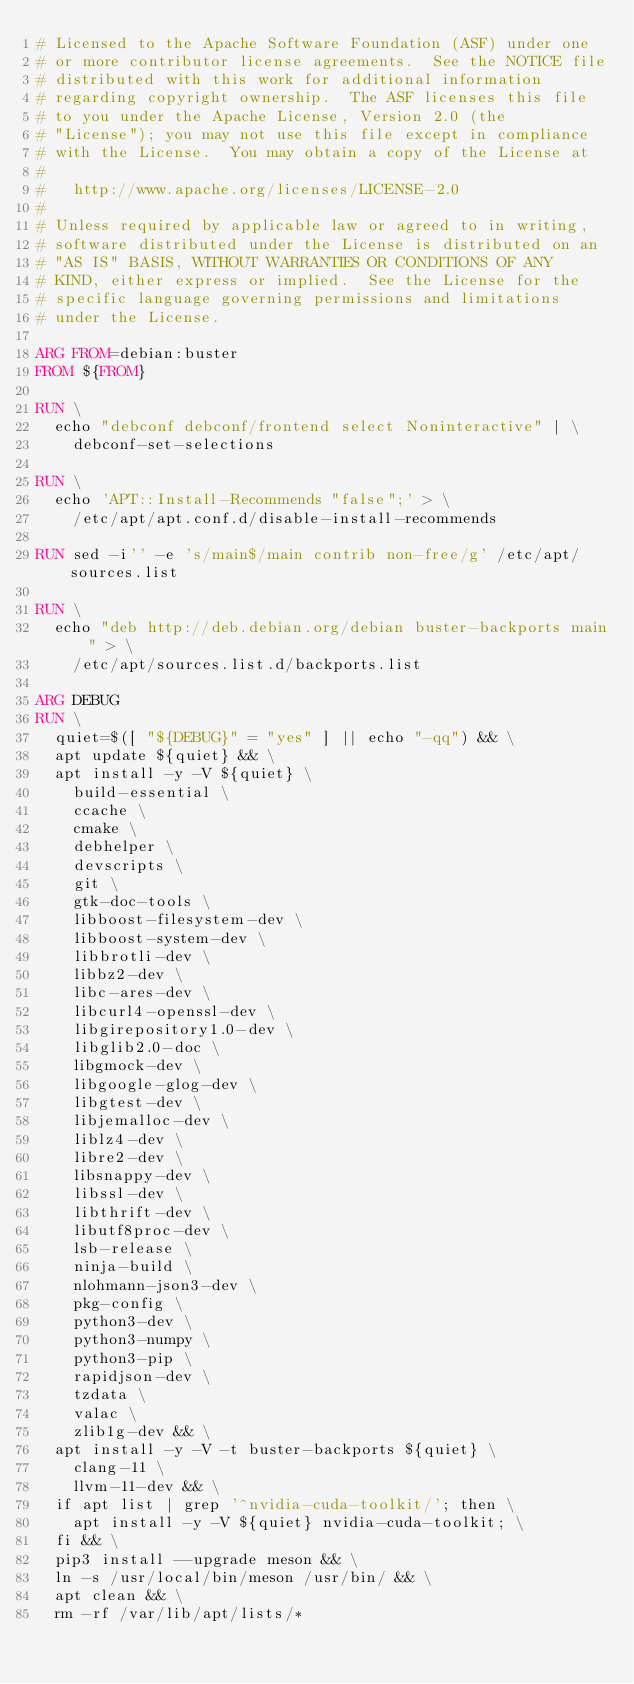Convert code to text. <code><loc_0><loc_0><loc_500><loc_500><_Dockerfile_># Licensed to the Apache Software Foundation (ASF) under one
# or more contributor license agreements.  See the NOTICE file
# distributed with this work for additional information
# regarding copyright ownership.  The ASF licenses this file
# to you under the Apache License, Version 2.0 (the
# "License"); you may not use this file except in compliance
# with the License.  You may obtain a copy of the License at
#
#   http://www.apache.org/licenses/LICENSE-2.0
#
# Unless required by applicable law or agreed to in writing,
# software distributed under the License is distributed on an
# "AS IS" BASIS, WITHOUT WARRANTIES OR CONDITIONS OF ANY
# KIND, either express or implied.  See the License for the
# specific language governing permissions and limitations
# under the License.

ARG FROM=debian:buster
FROM ${FROM}

RUN \
  echo "debconf debconf/frontend select Noninteractive" | \
    debconf-set-selections

RUN \
  echo 'APT::Install-Recommends "false";' > \
    /etc/apt/apt.conf.d/disable-install-recommends

RUN sed -i'' -e 's/main$/main contrib non-free/g' /etc/apt/sources.list

RUN \
  echo "deb http://deb.debian.org/debian buster-backports main" > \
    /etc/apt/sources.list.d/backports.list

ARG DEBUG
RUN \
  quiet=$([ "${DEBUG}" = "yes" ] || echo "-qq") && \
  apt update ${quiet} && \
  apt install -y -V ${quiet} \
    build-essential \
    ccache \
    cmake \
    debhelper \
    devscripts \
    git \
    gtk-doc-tools \
    libboost-filesystem-dev \
    libboost-system-dev \
    libbrotli-dev \
    libbz2-dev \
    libc-ares-dev \
    libcurl4-openssl-dev \
    libgirepository1.0-dev \
    libglib2.0-doc \
    libgmock-dev \
    libgoogle-glog-dev \
    libgtest-dev \
    libjemalloc-dev \
    liblz4-dev \
    libre2-dev \
    libsnappy-dev \
    libssl-dev \
    libthrift-dev \
    libutf8proc-dev \
    lsb-release \
    ninja-build \
    nlohmann-json3-dev \
    pkg-config \
    python3-dev \
    python3-numpy \
    python3-pip \
    rapidjson-dev \
    tzdata \
    valac \
    zlib1g-dev && \
  apt install -y -V -t buster-backports ${quiet} \
    clang-11 \
    llvm-11-dev && \
  if apt list | grep '^nvidia-cuda-toolkit/'; then \
    apt install -y -V ${quiet} nvidia-cuda-toolkit; \
  fi && \
  pip3 install --upgrade meson && \
  ln -s /usr/local/bin/meson /usr/bin/ && \
  apt clean && \
  rm -rf /var/lib/apt/lists/*
</code> 